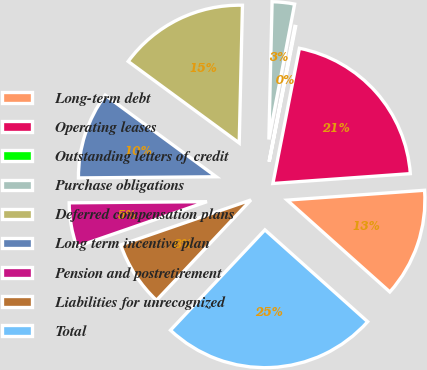<chart> <loc_0><loc_0><loc_500><loc_500><pie_chart><fcel>Long-term debt<fcel>Operating leases<fcel>Outstanding letters of credit<fcel>Purchase obligations<fcel>Deferred compensation plans<fcel>Long term incentive plan<fcel>Pension and postretirement<fcel>Liabilities for unrecognized<fcel>Total<nl><fcel>12.75%<fcel>20.78%<fcel>0.09%<fcel>2.62%<fcel>15.29%<fcel>10.22%<fcel>5.16%<fcel>7.69%<fcel>25.41%<nl></chart> 